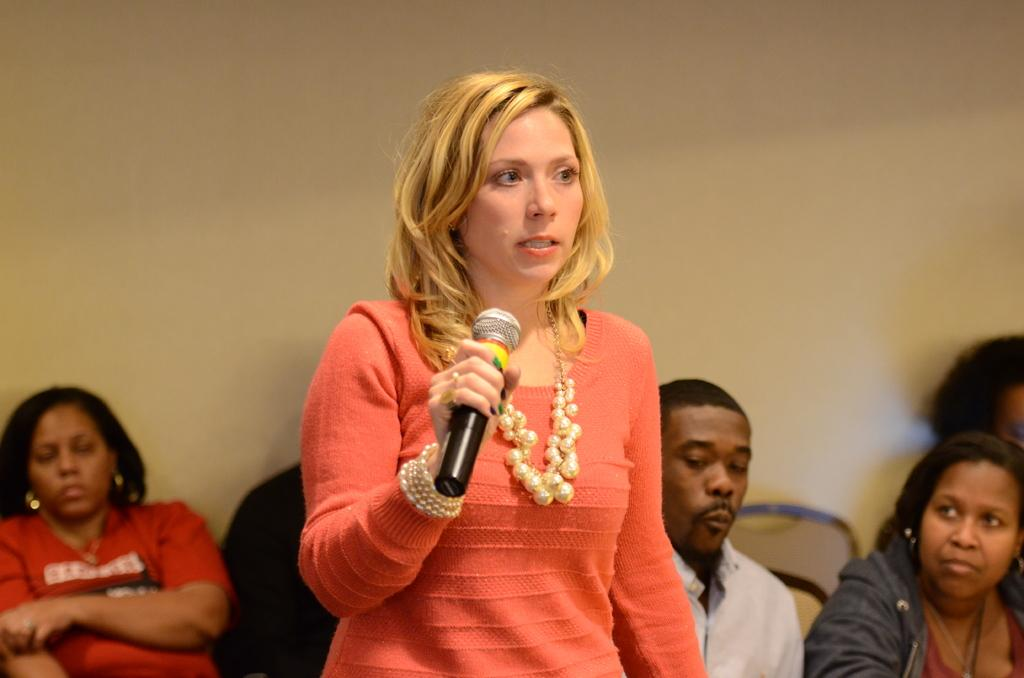What are the people in the image doing? The people in the image are sitting. What is the lady standing in front of the sitting people doing? The lady is holding a microphone in her hand. What can be seen in the background of the image? There is a cream-colored wall in the background of the image. Where is the trail that leads to the dolls in the image? There is no trail or dolls present in the image. 